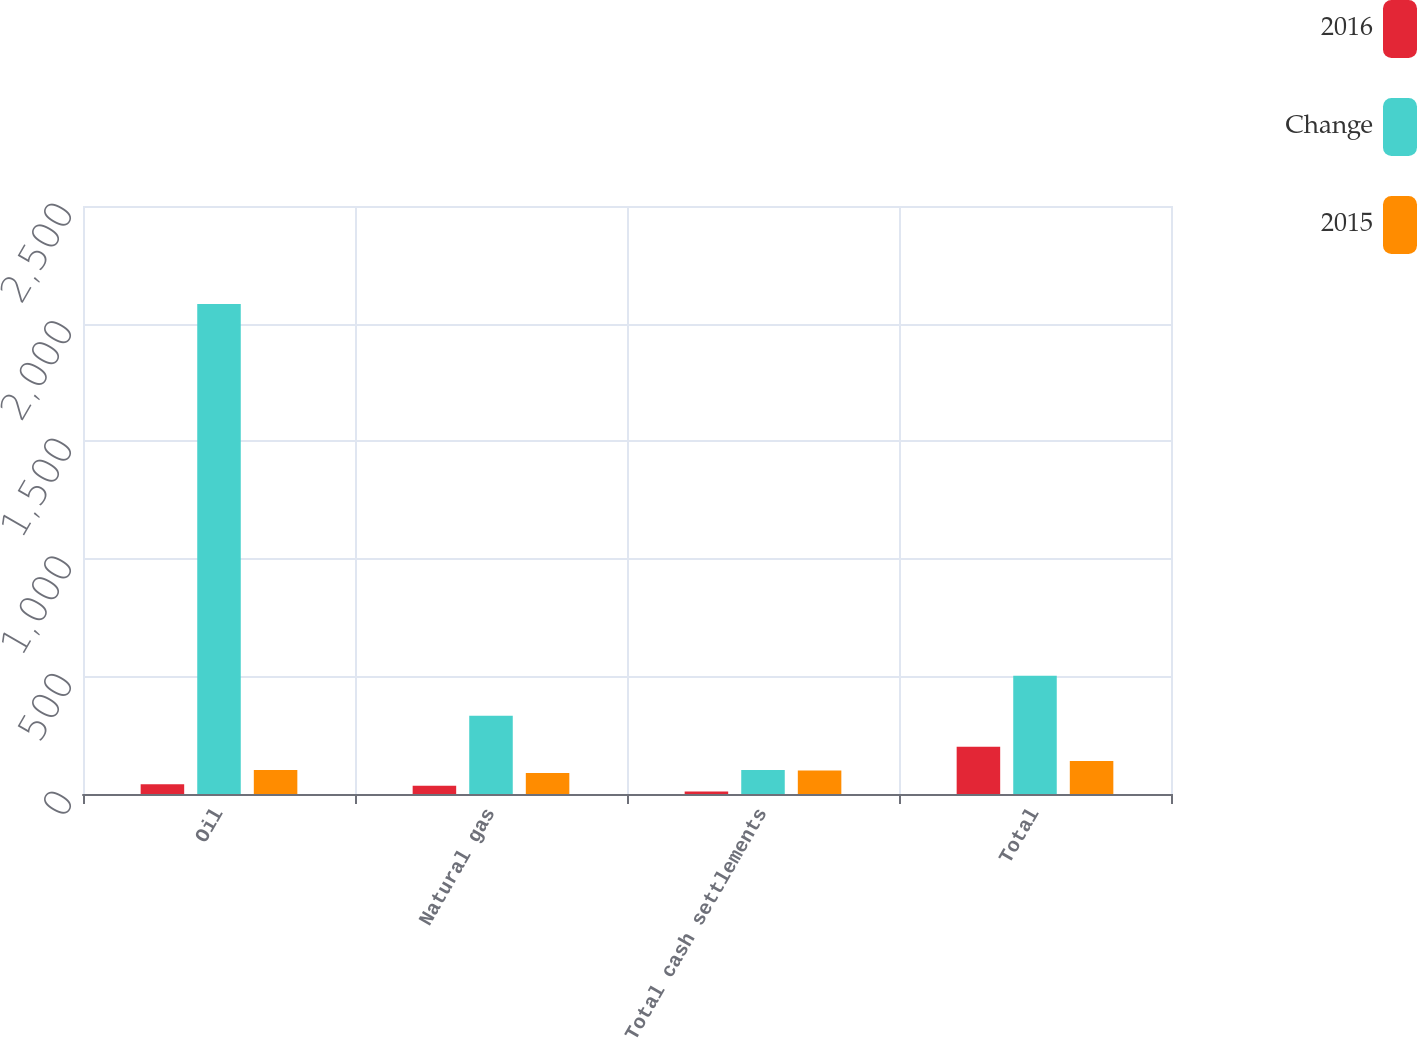Convert chart to OTSL. <chart><loc_0><loc_0><loc_500><loc_500><stacked_bar_chart><ecel><fcel>Oil<fcel>Natural gas<fcel>Total cash settlements<fcel>Total<nl><fcel>2016<fcel>41<fcel>35<fcel>11<fcel>201<nl><fcel>Change<fcel>2083<fcel>333<fcel>102<fcel>503<nl><fcel>2015<fcel>102<fcel>89<fcel>100<fcel>140<nl></chart> 